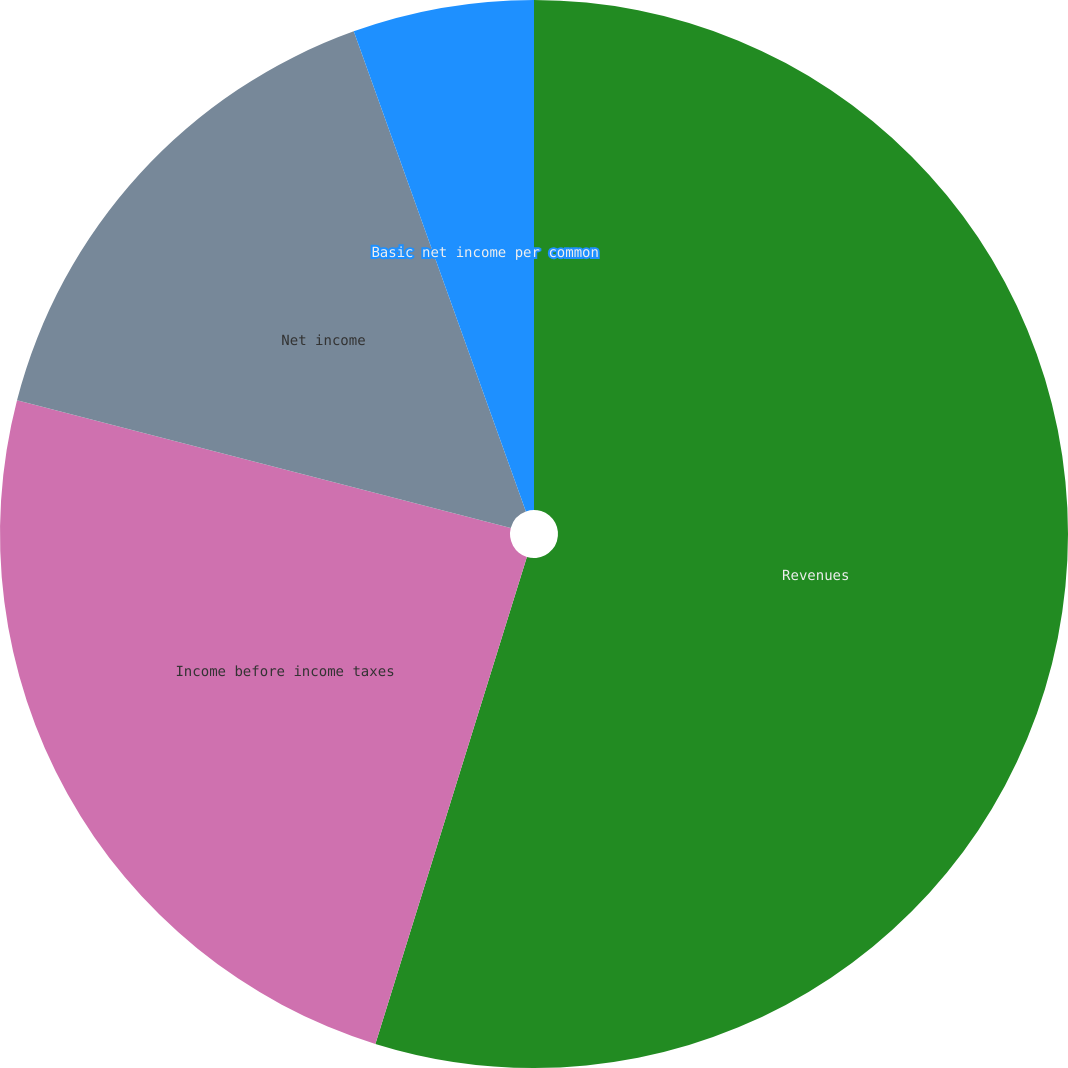Convert chart to OTSL. <chart><loc_0><loc_0><loc_500><loc_500><pie_chart><fcel>Revenues<fcel>Income before income taxes<fcel>Net income<fcel>Basic net income per common<fcel>Diluted net income per common<nl><fcel>54.8%<fcel>24.23%<fcel>15.49%<fcel>5.48%<fcel>0.0%<nl></chart> 